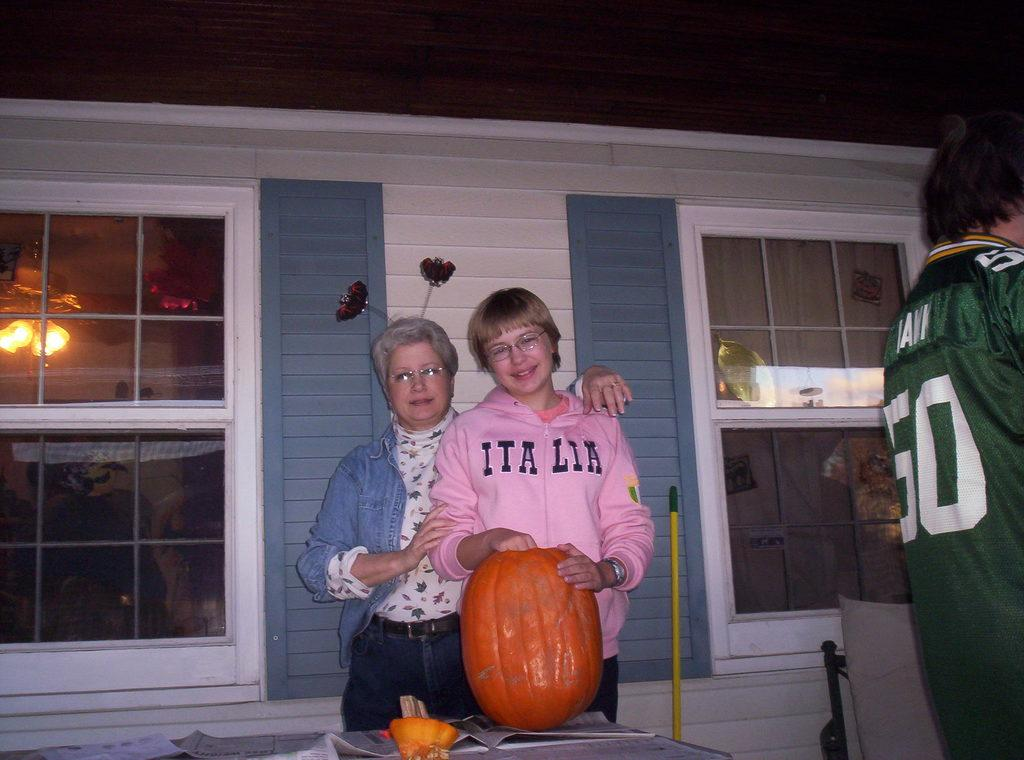<image>
Summarize the visual content of the image. A person in a pink Italia sweatshirt has a pumpkin they are carving. 